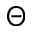<formula> <loc_0><loc_0><loc_500><loc_500>\Theta</formula> 